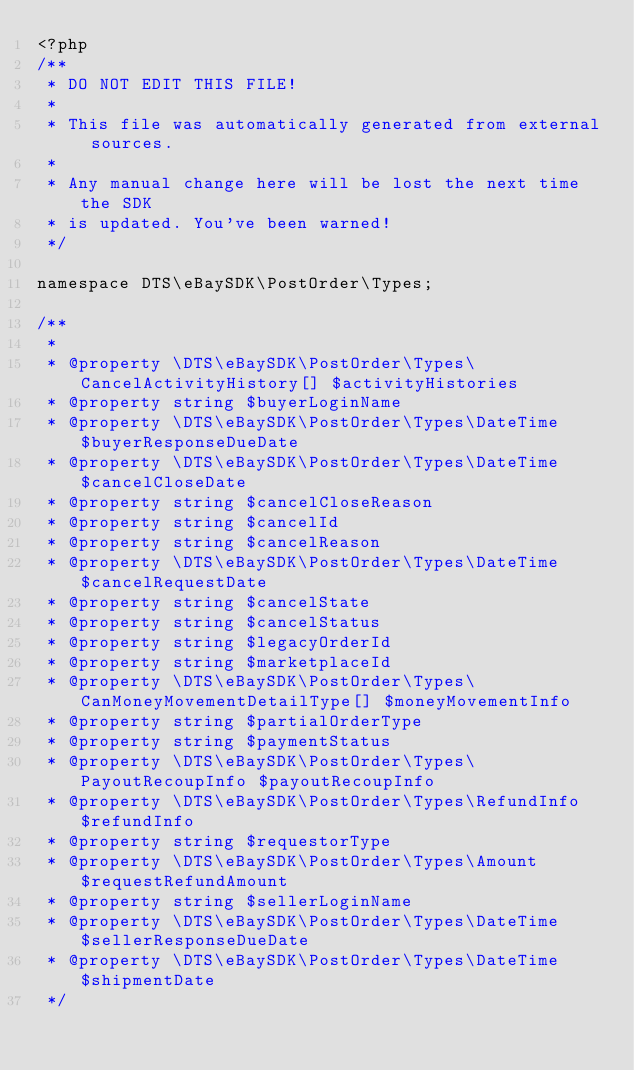<code> <loc_0><loc_0><loc_500><loc_500><_PHP_><?php
/**
 * DO NOT EDIT THIS FILE!
 *
 * This file was automatically generated from external sources.
 *
 * Any manual change here will be lost the next time the SDK
 * is updated. You've been warned!
 */

namespace DTS\eBaySDK\PostOrder\Types;

/**
 *
 * @property \DTS\eBaySDK\PostOrder\Types\CancelActivityHistory[] $activityHistories
 * @property string $buyerLoginName
 * @property \DTS\eBaySDK\PostOrder\Types\DateTime $buyerResponseDueDate
 * @property \DTS\eBaySDK\PostOrder\Types\DateTime $cancelCloseDate
 * @property string $cancelCloseReason
 * @property string $cancelId
 * @property string $cancelReason
 * @property \DTS\eBaySDK\PostOrder\Types\DateTime $cancelRequestDate
 * @property string $cancelState
 * @property string $cancelStatus
 * @property string $legacyOrderId
 * @property string $marketplaceId
 * @property \DTS\eBaySDK\PostOrder\Types\CanMoneyMovementDetailType[] $moneyMovementInfo
 * @property string $partialOrderType
 * @property string $paymentStatus
 * @property \DTS\eBaySDK\PostOrder\Types\PayoutRecoupInfo $payoutRecoupInfo
 * @property \DTS\eBaySDK\PostOrder\Types\RefundInfo $refundInfo
 * @property string $requestorType
 * @property \DTS\eBaySDK\PostOrder\Types\Amount $requestRefundAmount
 * @property string $sellerLoginName
 * @property \DTS\eBaySDK\PostOrder\Types\DateTime $sellerResponseDueDate
 * @property \DTS\eBaySDK\PostOrder\Types\DateTime $shipmentDate
 */</code> 